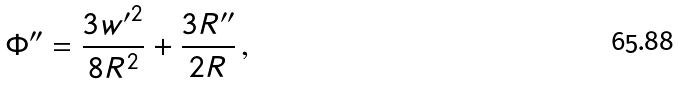<formula> <loc_0><loc_0><loc_500><loc_500>\Phi ^ { \prime \prime } = \frac { 3 { w ^ { \prime } } ^ { 2 } } { 8 R ^ { 2 } } + \frac { 3 R ^ { \prime \prime } } { 2 R } \, ,</formula> 